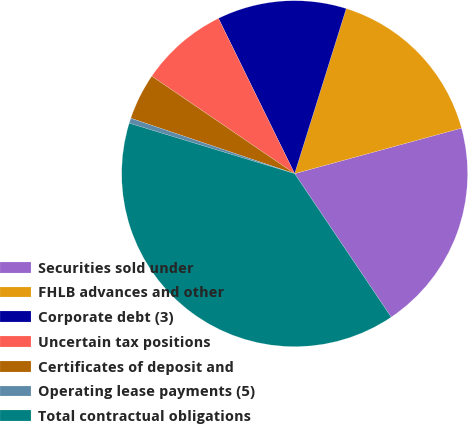<chart> <loc_0><loc_0><loc_500><loc_500><pie_chart><fcel>Securities sold under<fcel>FHLB advances and other<fcel>Corporate debt (3)<fcel>Uncertain tax positions<fcel>Certificates of deposit and<fcel>Operating lease payments (5)<fcel>Total contractual obligations<nl><fcel>19.81%<fcel>15.94%<fcel>12.08%<fcel>8.21%<fcel>4.34%<fcel>0.48%<fcel>39.14%<nl></chart> 